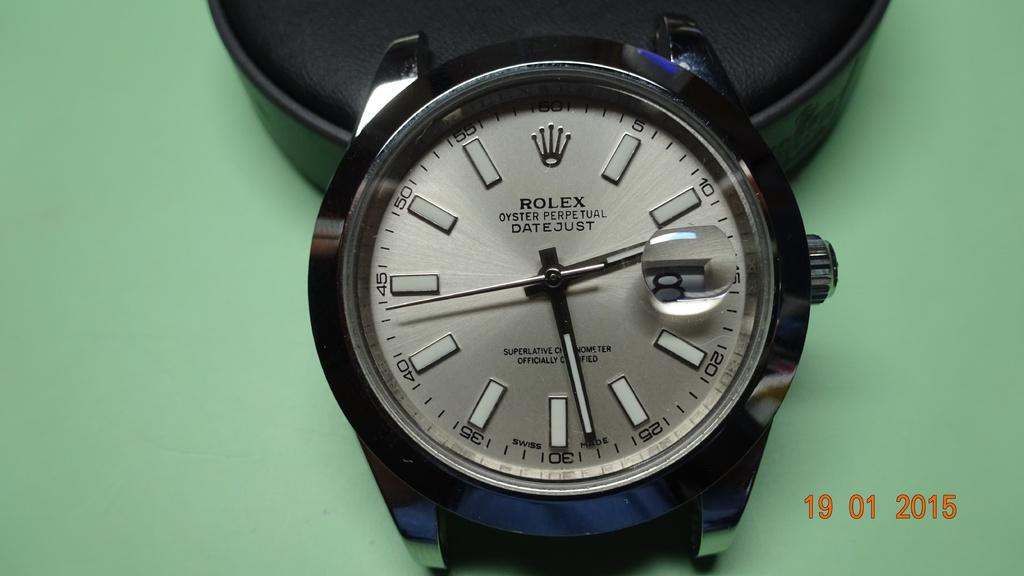<image>
Describe the image concisely. Black and silver rolex watch with the time on it 